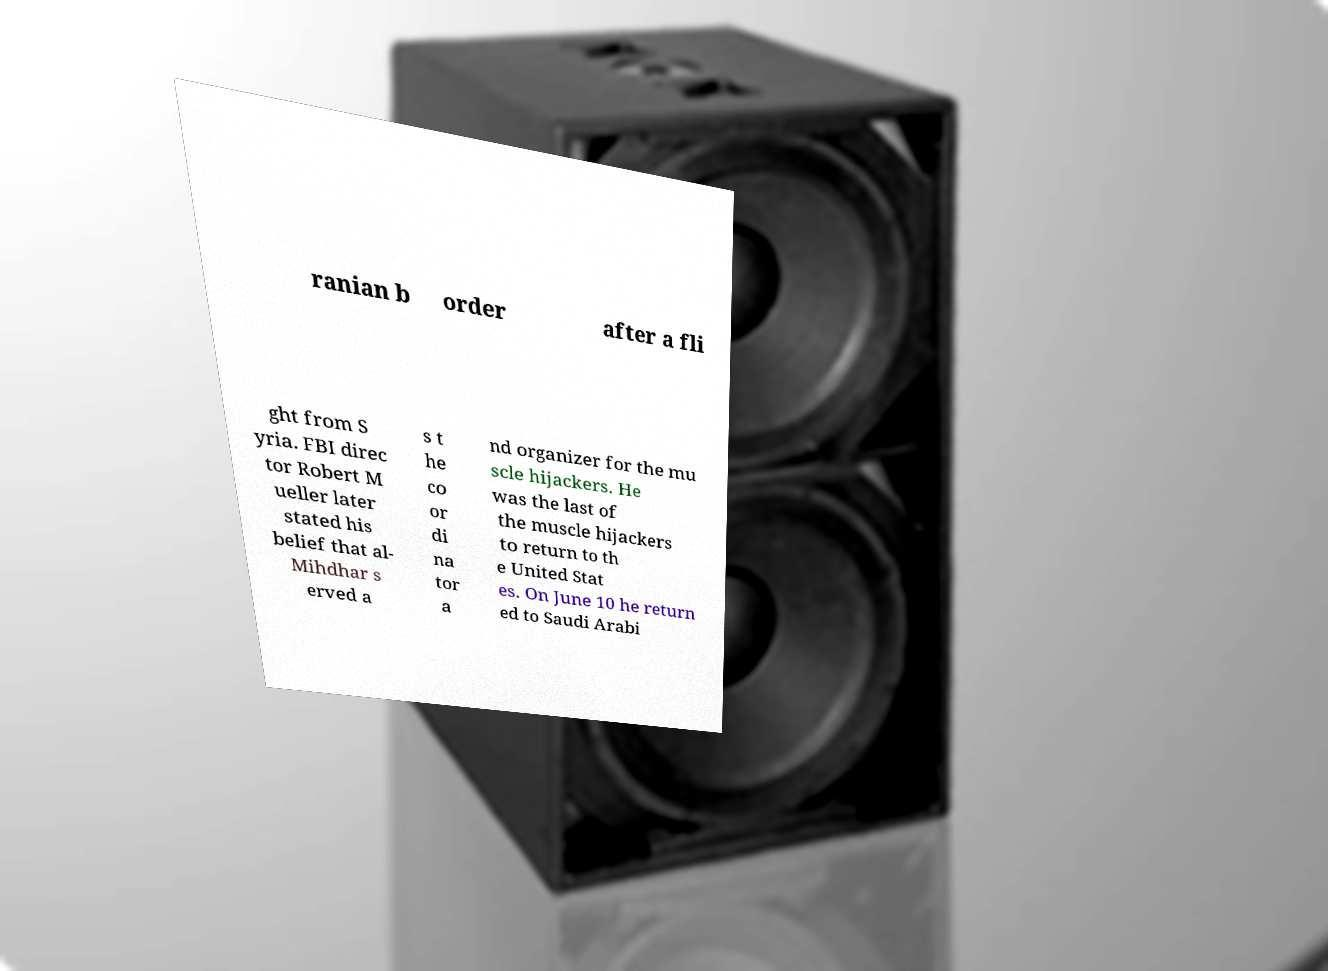Could you extract and type out the text from this image? ranian b order after a fli ght from S yria. FBI direc tor Robert M ueller later stated his belief that al- Mihdhar s erved a s t he co or di na tor a nd organizer for the mu scle hijackers. He was the last of the muscle hijackers to return to th e United Stat es. On June 10 he return ed to Saudi Arabi 